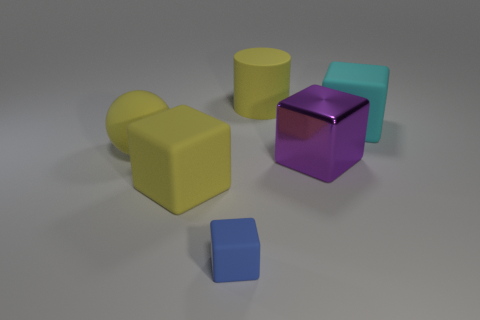There is another yellow thing that is the same shape as the metallic object; what is its size?
Your answer should be compact. Large. What is the material of the large cylinder that is the same color as the large rubber sphere?
Ensure brevity in your answer.  Rubber. There is another metallic object that is the same shape as the blue thing; what color is it?
Keep it short and to the point. Purple. Do the large shiny object and the yellow object right of the blue cube have the same shape?
Provide a succinct answer. No. What number of other objects are there of the same material as the sphere?
Provide a short and direct response. 4. Is the color of the metal object the same as the big rubber object that is in front of the yellow sphere?
Offer a terse response. No. What is the big yellow object that is behind the cyan block made of?
Your response must be concise. Rubber. Is there a sphere that has the same color as the rubber cylinder?
Your answer should be very brief. Yes. What color is the shiny cube that is the same size as the cyan matte thing?
Your answer should be very brief. Purple. How many tiny objects are gray rubber cylinders or purple shiny things?
Offer a terse response. 0. 